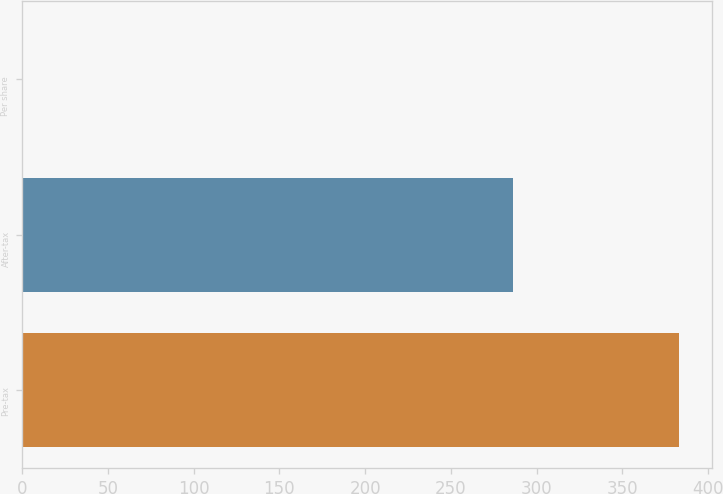Convert chart. <chart><loc_0><loc_0><loc_500><loc_500><bar_chart><fcel>Pre-tax<fcel>After-tax<fcel>Per share<nl><fcel>383<fcel>286<fcel>0.18<nl></chart> 